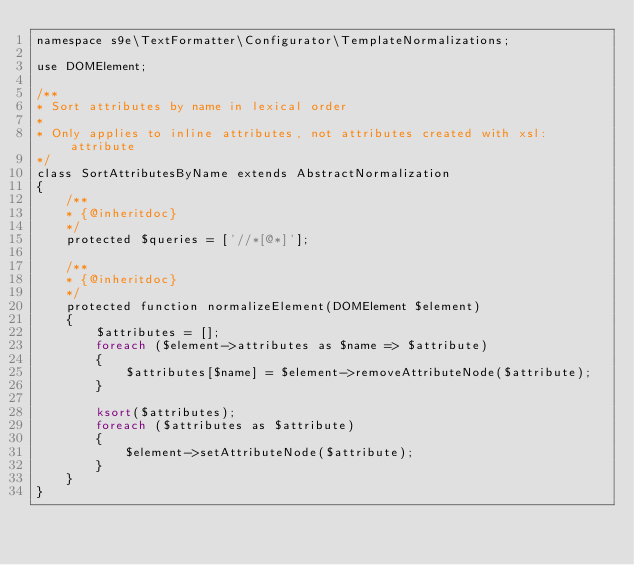Convert code to text. <code><loc_0><loc_0><loc_500><loc_500><_PHP_>namespace s9e\TextFormatter\Configurator\TemplateNormalizations;

use DOMElement;

/**
* Sort attributes by name in lexical order
*
* Only applies to inline attributes, not attributes created with xsl:attribute
*/
class SortAttributesByName extends AbstractNormalization
{
	/**
	* {@inheritdoc}
	*/
	protected $queries = ['//*[@*]'];

	/**
	* {@inheritdoc}
	*/
	protected function normalizeElement(DOMElement $element)
	{
		$attributes = [];
		foreach ($element->attributes as $name => $attribute)
		{
			$attributes[$name] = $element->removeAttributeNode($attribute);
		}

		ksort($attributes);
		foreach ($attributes as $attribute)
		{
			$element->setAttributeNode($attribute);
		}
	}
}</code> 